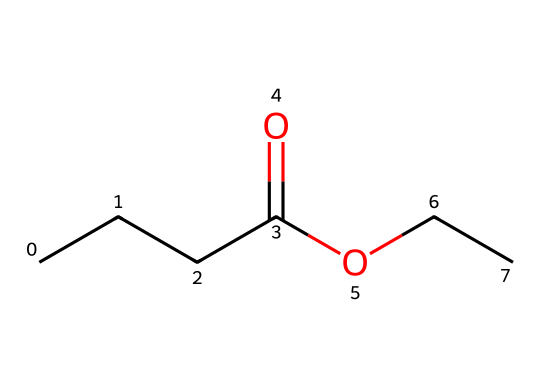What is the molecular formula of ethyl butyrate? To determine the molecular formula, you count the number of carbon (C), hydrogen (H), and oxygen (O) atoms in the SMILES representation. There are 4 carbons (from the butyrate part) and 2 carbons (from the ethyl part), totaling 6 carbons (C6). There are 12 hydrogens (H12) and 2 oxygens (O2), leading to the formula C6H12O2.
Answer: C6H12O2 How many oxygen atoms are in ethyl butyrate? By examining the SMILES representation, you can see there are two occurrences of the letter 'O,' which signifies the two oxygen atoms present in the molecule.
Answer: 2 What functional group is present in ethyl butyrate? The presence of the "CCCC(=O)O" portion in the SMILES indicates that there is a carboxylate ester functional group, characterized by the -COO- linkage.
Answer: ester Which part of the structure provides the fruity aroma? The presence of the butyrate group (the C4 portion) is often associated with fruity scents in flavoring and fragrance chemistry. This particular group is key to the fruity aroma of ethyl butyrate.
Answer: butyrate How many total bonds are in ethyl butyrate? Analyzing the structure, there are 6 carbon-carbon bonds (C-C) and 7 carbon-hydrogen (C-H) bonds, and 1 carbon-oxygen double bond (C=O) along with 1 carbon-oxygen single bond (C-O). Adding these gives a total of 15 bonds.
Answer: 15 What type of chemical is ethyl butyrate specifically used for? Ethyl butyrate is widely used as a flavor and fragrance compound in food and air freshening products due to its pleasant fruity scent.
Answer: flavors and fragrances 